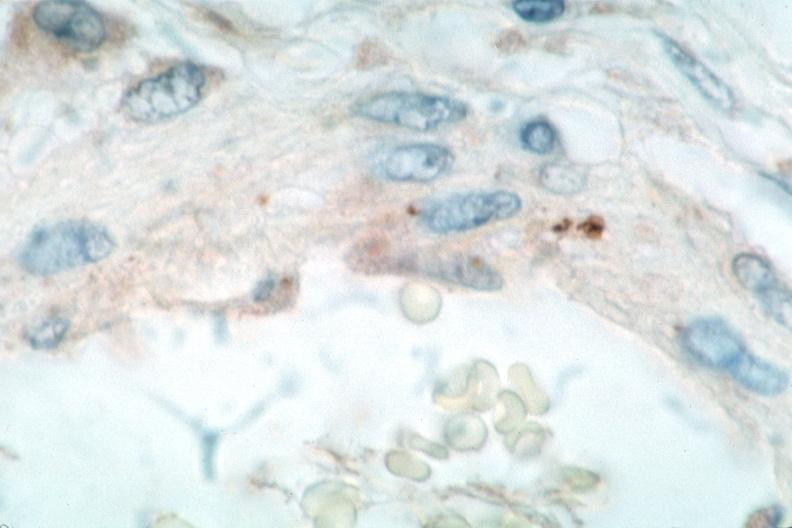where is this from?
Answer the question using a single word or phrase. Vasculature 